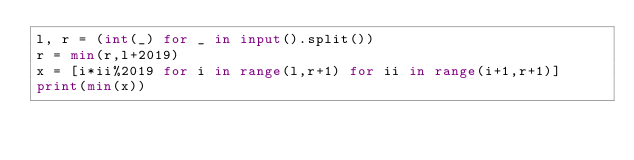<code> <loc_0><loc_0><loc_500><loc_500><_Python_>l, r = (int(_) for _ in input().split())
r = min(r,l+2019)
x = [i*ii%2019 for i in range(l,r+1) for ii in range(i+1,r+1)]
print(min(x))
</code> 